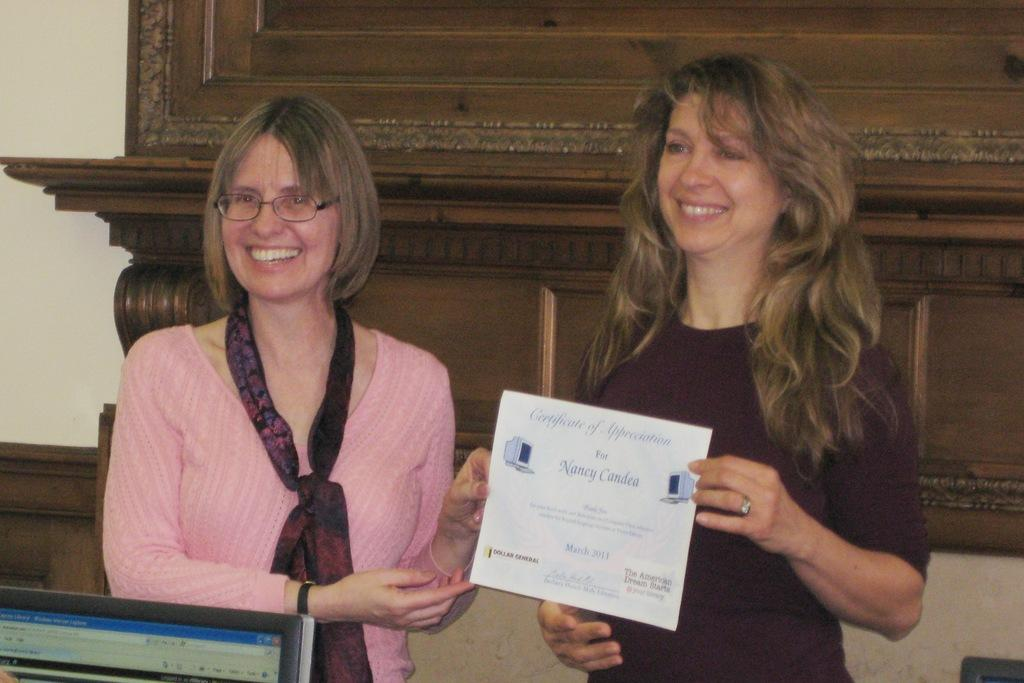<image>
Create a compact narrative representing the image presented. Two woman stand at a podium holding a Certificate of Appreciation for Nancy Candea 